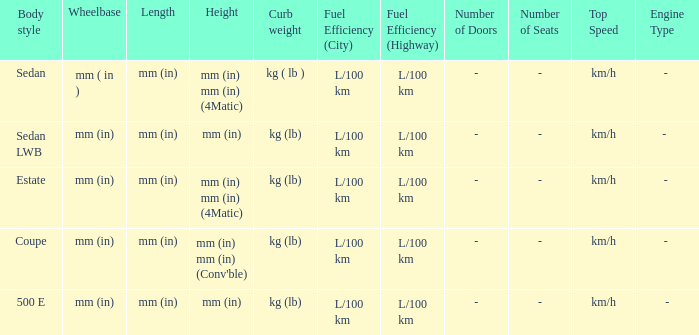What's the length of the model with 500 E body style? Mm (in). 